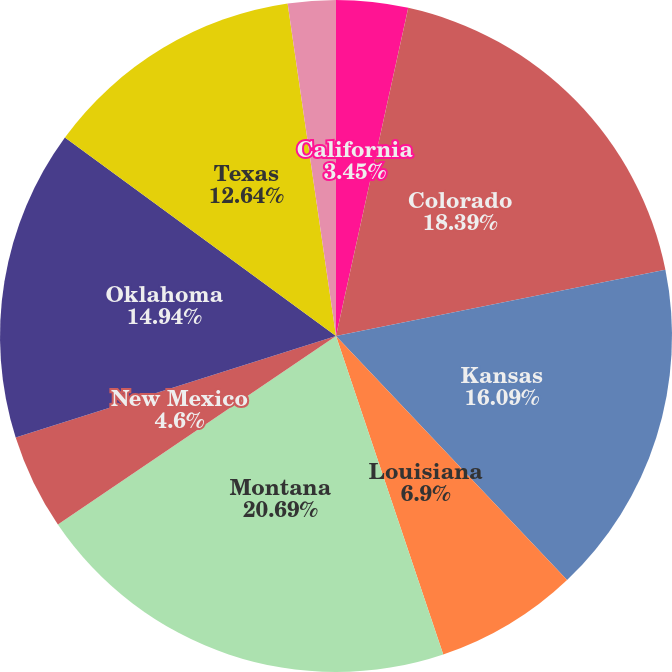<chart> <loc_0><loc_0><loc_500><loc_500><pie_chart><fcel>California<fcel>Colorado<fcel>Kansas<fcel>Louisiana<fcel>Mississippi<fcel>Montana<fcel>New Mexico<fcel>Oklahoma<fcel>Texas<fcel>Utah<nl><fcel>3.45%<fcel>18.39%<fcel>16.09%<fcel>6.9%<fcel>0.0%<fcel>20.69%<fcel>4.6%<fcel>14.94%<fcel>12.64%<fcel>2.3%<nl></chart> 